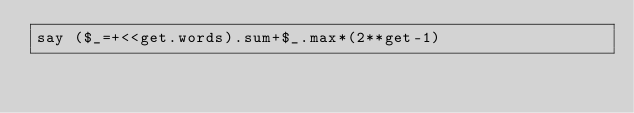Convert code to text. <code><loc_0><loc_0><loc_500><loc_500><_Perl_>say ($_=+<<get.words).sum+$_.max*(2**get-1)</code> 